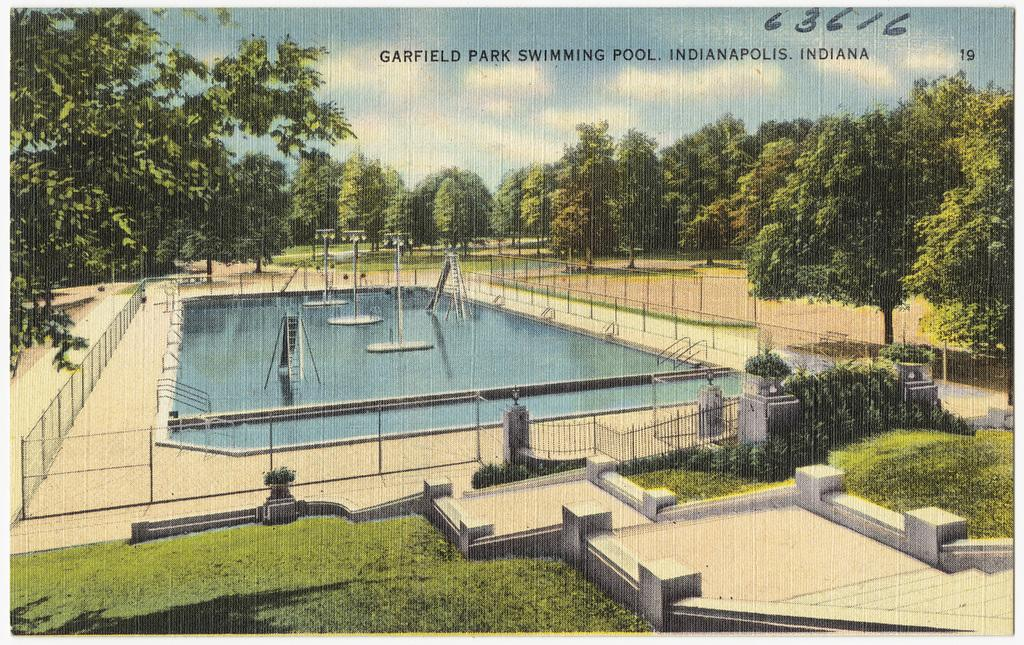What is featured on the poster in the image? The poster depicts a swimming pool and poles. What other elements can be seen in the poster? Trees and the sky are visible in the poster. Is there any text on the image? Yes, there is some text on the image. What type of door can be seen in the image? There is no door present in the image; it features a poster with a swimming pool, poles, trees, and sky. Can you provide an example of a scientific concept that is illustrated in the image? The image does not depict any scientific concepts; it is a poster with a swimming pool, poles, trees, and sky. 